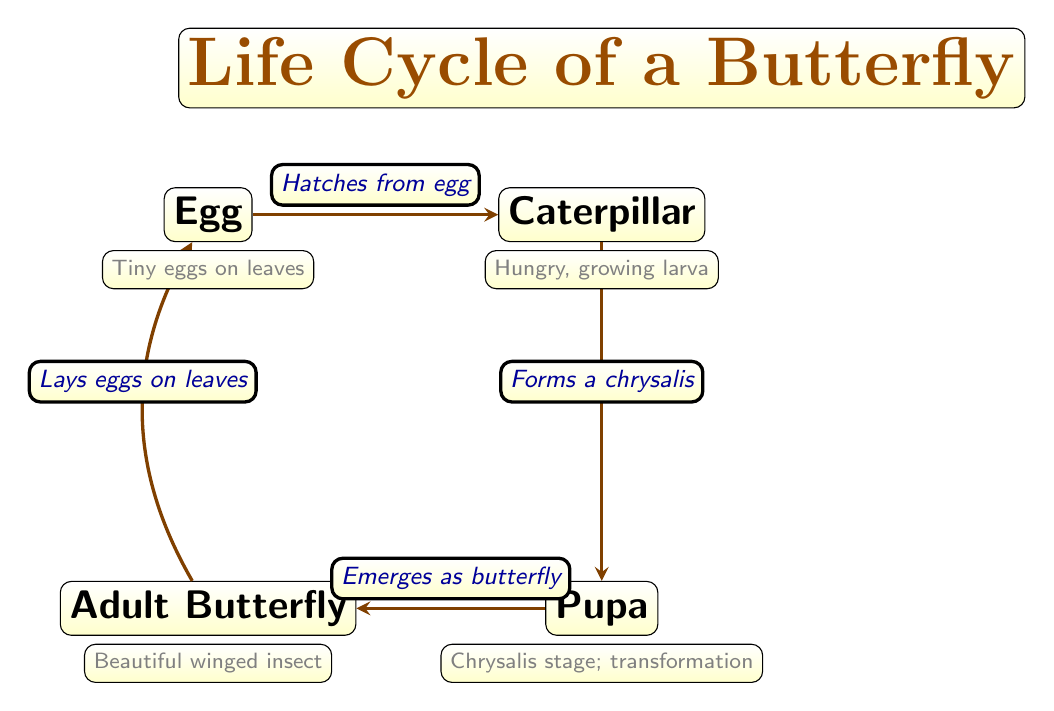What are the four stages in the life cycle of a butterfly? The diagram shows four stages: Egg, Caterpillar, Pupa, and Adult Butterfly. These are clearly labeled nodes within the diagram.
Answer: Egg, Caterpillar, Pupa, Adult Butterfly What does the caterpillar stage represent? The diagram describes the Caterpillar as a "Hungry, growing larva," which indicates its role and characteristics during this stage.
Answer: Hungry, growing larva How does the life cycle begin? According to the diagram, the life cycle begins with an Egg, as it is the starting node from where the cycle flows.
Answer: Egg What does the adult butterfly do as shown in the diagram? The diagram states that the Adult Butterfly "Lays eggs on leaves," indicating its role in the life cycle.
Answer: Lays eggs on leaves What happens after the caterpillar forms a chrysalis? The diagram indicates that after the Caterpillar forms a chrysalis, it enters the Pupa stage, leading to the next stage of development.
Answer: Enters Pupa stage How many edges are there in the diagram? The diagram features 4 edges connecting the stages of the butterfly's life cycle together. This can be visually counted by following the arrows between the stages.
Answer: 4 Which stage transforms into an adult butterfly? Based on the diagram, the Pupa stage is the one that "Emerges as butterfly," indicating its transformation into the next stage.
Answer: Pupa What color represents the node descriptions in the diagram? The descriptions of each stage in the diagram are written in gray, which can be observed from the text style used in the description nodes.
Answer: Gray What kind of insect does the life cycle culminate in? The final stage of the diagram is labeled as "Beautiful winged insect," which describes the adult butterfly as the culmination of the life cycle.
Answer: Butterfly 